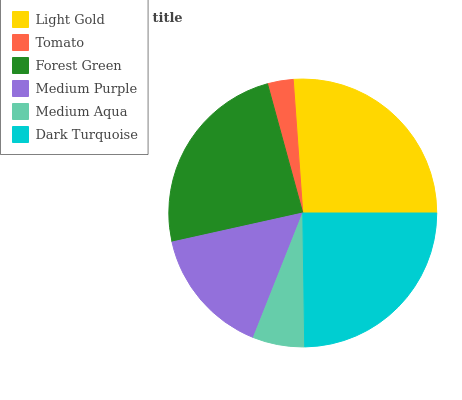Is Tomato the minimum?
Answer yes or no. Yes. Is Light Gold the maximum?
Answer yes or no. Yes. Is Forest Green the minimum?
Answer yes or no. No. Is Forest Green the maximum?
Answer yes or no. No. Is Forest Green greater than Tomato?
Answer yes or no. Yes. Is Tomato less than Forest Green?
Answer yes or no. Yes. Is Tomato greater than Forest Green?
Answer yes or no. No. Is Forest Green less than Tomato?
Answer yes or no. No. Is Forest Green the high median?
Answer yes or no. Yes. Is Medium Purple the low median?
Answer yes or no. Yes. Is Tomato the high median?
Answer yes or no. No. Is Light Gold the low median?
Answer yes or no. No. 